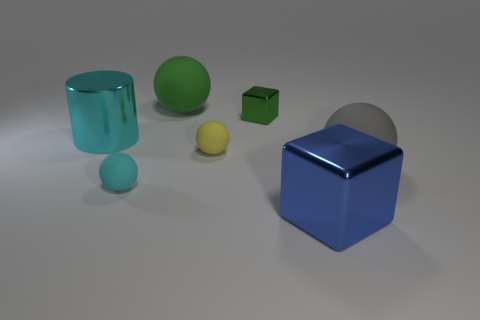Subtract all green cylinders. Subtract all green blocks. How many cylinders are left? 1 Subtract all blue cubes. How many yellow cylinders are left? 0 Add 6 cyans. How many big things exist? 0 Subtract all gray rubber objects. Subtract all green rubber blocks. How many objects are left? 6 Add 3 small rubber things. How many small rubber things are left? 5 Add 7 metal blocks. How many metal blocks exist? 9 Add 2 blue blocks. How many objects exist? 9 Subtract all gray spheres. How many spheres are left? 3 Subtract all big gray rubber balls. How many balls are left? 3 Subtract 1 gray balls. How many objects are left? 6 